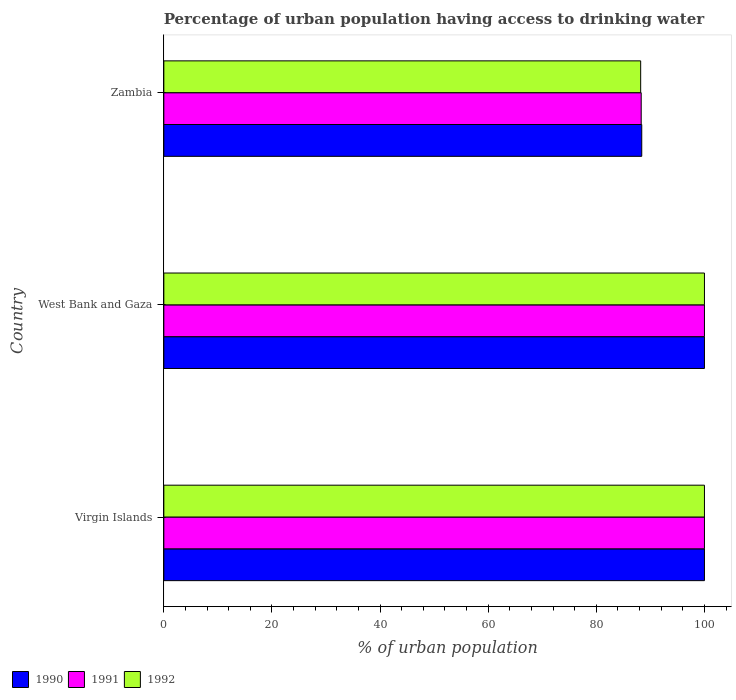How many different coloured bars are there?
Provide a succinct answer. 3. How many groups of bars are there?
Offer a very short reply. 3. What is the label of the 2nd group of bars from the top?
Your response must be concise. West Bank and Gaza. In how many cases, is the number of bars for a given country not equal to the number of legend labels?
Offer a very short reply. 0. Across all countries, what is the minimum percentage of urban population having access to drinking water in 1990?
Give a very brief answer. 88.4. In which country was the percentage of urban population having access to drinking water in 1992 maximum?
Provide a short and direct response. Virgin Islands. In which country was the percentage of urban population having access to drinking water in 1990 minimum?
Give a very brief answer. Zambia. What is the total percentage of urban population having access to drinking water in 1991 in the graph?
Offer a very short reply. 288.3. What is the difference between the percentage of urban population having access to drinking water in 1990 in Virgin Islands and that in Zambia?
Offer a terse response. 11.6. What is the difference between the percentage of urban population having access to drinking water in 1992 in Virgin Islands and the percentage of urban population having access to drinking water in 1990 in Zambia?
Offer a very short reply. 11.6. What is the average percentage of urban population having access to drinking water in 1991 per country?
Your answer should be compact. 96.1. What is the difference between the percentage of urban population having access to drinking water in 1992 and percentage of urban population having access to drinking water in 1991 in Zambia?
Offer a terse response. -0.1. What is the ratio of the percentage of urban population having access to drinking water in 1991 in Virgin Islands to that in Zambia?
Offer a terse response. 1.13. Is the percentage of urban population having access to drinking water in 1991 in West Bank and Gaza less than that in Zambia?
Your response must be concise. No. What is the difference between the highest and the lowest percentage of urban population having access to drinking water in 1992?
Give a very brief answer. 11.8. What does the 2nd bar from the top in Virgin Islands represents?
Your answer should be compact. 1991. Is it the case that in every country, the sum of the percentage of urban population having access to drinking water in 1991 and percentage of urban population having access to drinking water in 1990 is greater than the percentage of urban population having access to drinking water in 1992?
Provide a short and direct response. Yes. How many bars are there?
Make the answer very short. 9. Are all the bars in the graph horizontal?
Your answer should be compact. Yes. Are the values on the major ticks of X-axis written in scientific E-notation?
Provide a short and direct response. No. Where does the legend appear in the graph?
Give a very brief answer. Bottom left. How many legend labels are there?
Provide a succinct answer. 3. What is the title of the graph?
Ensure brevity in your answer.  Percentage of urban population having access to drinking water. Does "2015" appear as one of the legend labels in the graph?
Provide a short and direct response. No. What is the label or title of the X-axis?
Your answer should be compact. % of urban population. What is the % of urban population of 1991 in West Bank and Gaza?
Your response must be concise. 100. What is the % of urban population of 1992 in West Bank and Gaza?
Offer a very short reply. 100. What is the % of urban population of 1990 in Zambia?
Provide a succinct answer. 88.4. What is the % of urban population in 1991 in Zambia?
Your answer should be very brief. 88.3. What is the % of urban population in 1992 in Zambia?
Your answer should be compact. 88.2. Across all countries, what is the maximum % of urban population in 1992?
Your answer should be compact. 100. Across all countries, what is the minimum % of urban population of 1990?
Offer a very short reply. 88.4. Across all countries, what is the minimum % of urban population in 1991?
Offer a terse response. 88.3. Across all countries, what is the minimum % of urban population in 1992?
Provide a short and direct response. 88.2. What is the total % of urban population of 1990 in the graph?
Your answer should be compact. 288.4. What is the total % of urban population in 1991 in the graph?
Your response must be concise. 288.3. What is the total % of urban population in 1992 in the graph?
Offer a terse response. 288.2. What is the difference between the % of urban population of 1991 in Virgin Islands and that in West Bank and Gaza?
Your response must be concise. 0. What is the difference between the % of urban population of 1992 in Virgin Islands and that in West Bank and Gaza?
Provide a succinct answer. 0. What is the difference between the % of urban population in 1992 in Virgin Islands and that in Zambia?
Make the answer very short. 11.8. What is the difference between the % of urban population of 1990 in West Bank and Gaza and that in Zambia?
Keep it short and to the point. 11.6. What is the difference between the % of urban population in 1992 in West Bank and Gaza and that in Zambia?
Provide a short and direct response. 11.8. What is the difference between the % of urban population in 1990 in Virgin Islands and the % of urban population in 1991 in West Bank and Gaza?
Offer a terse response. 0. What is the difference between the % of urban population in 1990 in Virgin Islands and the % of urban population in 1992 in West Bank and Gaza?
Your answer should be compact. 0. What is the difference between the % of urban population of 1991 in Virgin Islands and the % of urban population of 1992 in West Bank and Gaza?
Keep it short and to the point. 0. What is the difference between the % of urban population in 1990 in Virgin Islands and the % of urban population in 1991 in Zambia?
Keep it short and to the point. 11.7. What is the difference between the % of urban population in 1990 in Virgin Islands and the % of urban population in 1992 in Zambia?
Provide a succinct answer. 11.8. What is the average % of urban population in 1990 per country?
Offer a terse response. 96.13. What is the average % of urban population in 1991 per country?
Give a very brief answer. 96.1. What is the average % of urban population in 1992 per country?
Give a very brief answer. 96.07. What is the difference between the % of urban population in 1990 and % of urban population in 1991 in Virgin Islands?
Offer a very short reply. 0. What is the difference between the % of urban population in 1990 and % of urban population in 1991 in West Bank and Gaza?
Your response must be concise. 0. What is the difference between the % of urban population in 1991 and % of urban population in 1992 in West Bank and Gaza?
Keep it short and to the point. 0. What is the difference between the % of urban population of 1990 and % of urban population of 1991 in Zambia?
Keep it short and to the point. 0.1. What is the ratio of the % of urban population of 1990 in Virgin Islands to that in West Bank and Gaza?
Keep it short and to the point. 1. What is the ratio of the % of urban population of 1990 in Virgin Islands to that in Zambia?
Provide a short and direct response. 1.13. What is the ratio of the % of urban population in 1991 in Virgin Islands to that in Zambia?
Your response must be concise. 1.13. What is the ratio of the % of urban population in 1992 in Virgin Islands to that in Zambia?
Make the answer very short. 1.13. What is the ratio of the % of urban population of 1990 in West Bank and Gaza to that in Zambia?
Provide a short and direct response. 1.13. What is the ratio of the % of urban population in 1991 in West Bank and Gaza to that in Zambia?
Offer a terse response. 1.13. What is the ratio of the % of urban population in 1992 in West Bank and Gaza to that in Zambia?
Your answer should be very brief. 1.13. What is the difference between the highest and the second highest % of urban population in 1992?
Offer a very short reply. 0. What is the difference between the highest and the lowest % of urban population of 1990?
Ensure brevity in your answer.  11.6. What is the difference between the highest and the lowest % of urban population of 1991?
Give a very brief answer. 11.7. 